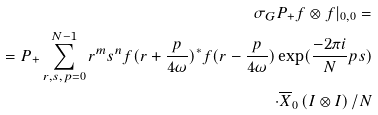<formula> <loc_0><loc_0><loc_500><loc_500>\sigma _ { G } P _ { + } f \otimes f | _ { 0 , 0 } = \\ = P _ { + } \sum _ { r , s , p = 0 } ^ { N - 1 } r ^ { m } s ^ { n } f ( r + \frac { p } { 4 \omega } ) ^ { \ast } f ( r - \frac { p } { 4 \omega } ) \exp ( \frac { - 2 \pi i } { N } p s ) \\ \cdot \overline { X } _ { 0 } \left ( I \otimes I \right ) / N</formula> 